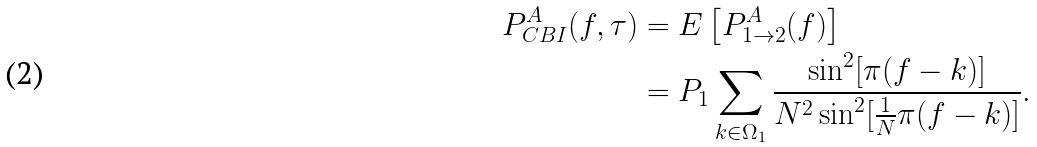<formula> <loc_0><loc_0><loc_500><loc_500>P _ { C B I } ^ { A } ( f , \tau ) & = E \left [ P ^ { A } _ { 1 \rightarrow 2 } ( f ) \right ] \\ & = P _ { 1 } \sum _ { k \in \Omega _ { 1 } } \frac { \sin ^ { 2 } [ \pi ( f - k ) ] } { N ^ { 2 } \sin ^ { 2 } [ \frac { 1 } { N } \pi ( f - k ) ] } .</formula> 